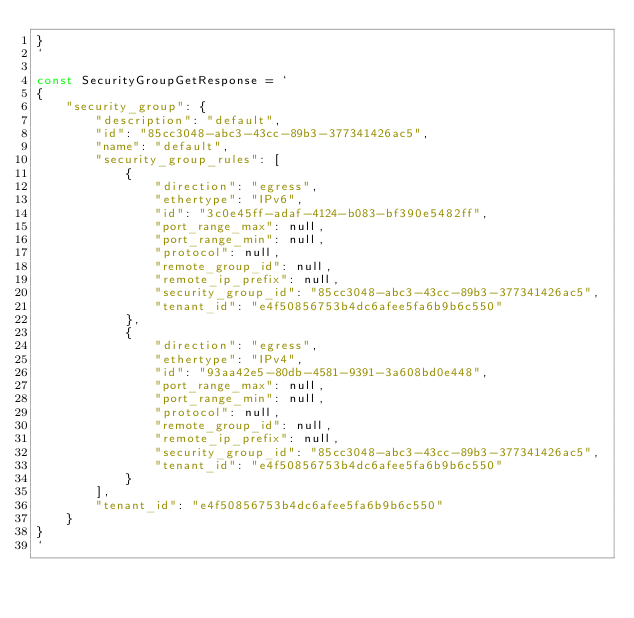Convert code to text. <code><loc_0><loc_0><loc_500><loc_500><_Go_>}
`

const SecurityGroupGetResponse = `
{
    "security_group": {
        "description": "default",
        "id": "85cc3048-abc3-43cc-89b3-377341426ac5",
        "name": "default",
        "security_group_rules": [
            {
                "direction": "egress",
                "ethertype": "IPv6",
                "id": "3c0e45ff-adaf-4124-b083-bf390e5482ff",
                "port_range_max": null,
                "port_range_min": null,
                "protocol": null,
                "remote_group_id": null,
                "remote_ip_prefix": null,
                "security_group_id": "85cc3048-abc3-43cc-89b3-377341426ac5",
                "tenant_id": "e4f50856753b4dc6afee5fa6b9b6c550"
            },
            {
                "direction": "egress",
                "ethertype": "IPv4",
                "id": "93aa42e5-80db-4581-9391-3a608bd0e448",
                "port_range_max": null,
                "port_range_min": null,
                "protocol": null,
                "remote_group_id": null,
                "remote_ip_prefix": null,
                "security_group_id": "85cc3048-abc3-43cc-89b3-377341426ac5",
                "tenant_id": "e4f50856753b4dc6afee5fa6b9b6c550"
            }
        ],
        "tenant_id": "e4f50856753b4dc6afee5fa6b9b6c550"
    }
}
`
</code> 